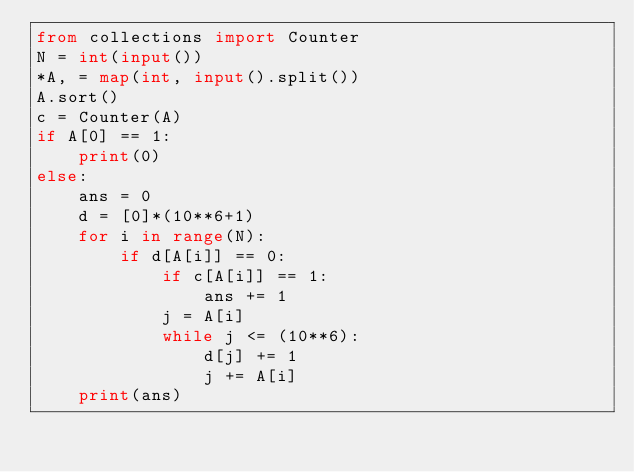<code> <loc_0><loc_0><loc_500><loc_500><_Python_>from collections import Counter
N = int(input())
*A, = map(int, input().split())
A.sort()
c = Counter(A)
if A[0] == 1:
    print(0)
else:
    ans = 0
    d = [0]*(10**6+1)
    for i in range(N):
        if d[A[i]] == 0:
            if c[A[i]] == 1:
                ans += 1
            j = A[i]
            while j <= (10**6):
                d[j] += 1
                j += A[i]
    print(ans)
</code> 